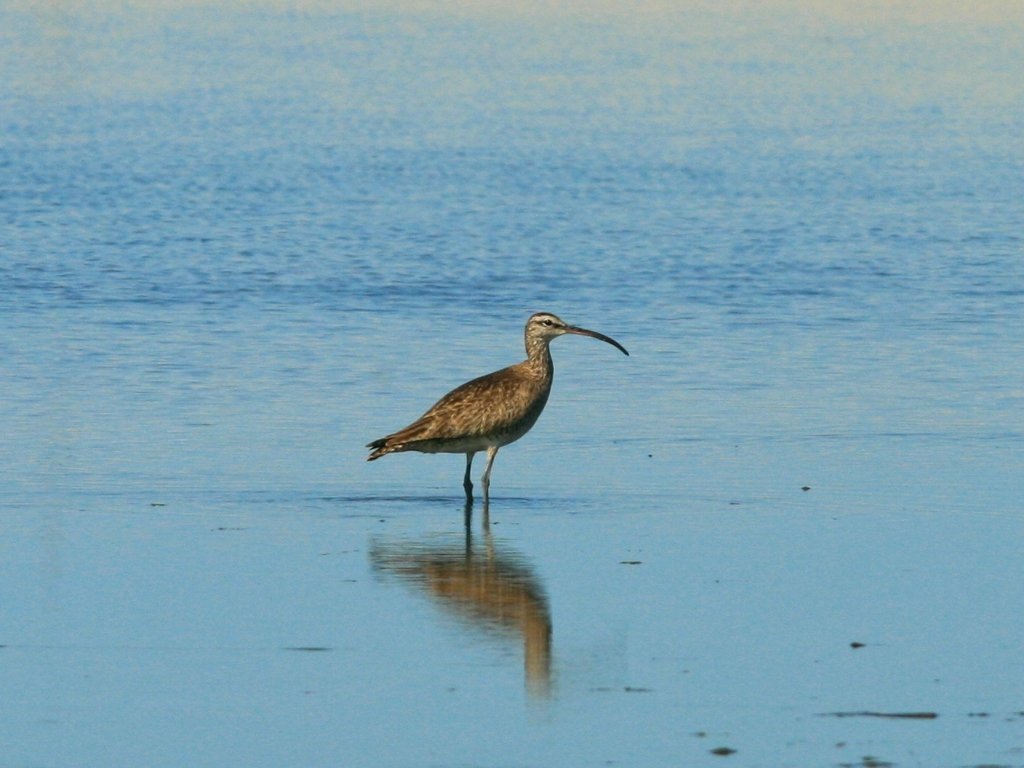Describe the environment shown in the picture and how it might relate to the time of day. The environment suggests a tranquil coastal or wetland area, likely captured during daytime given the brightness and weak shadow details of the bird. The lack of harsh shadows or strong light contrast indicates it might be either morning or late afternoon. 